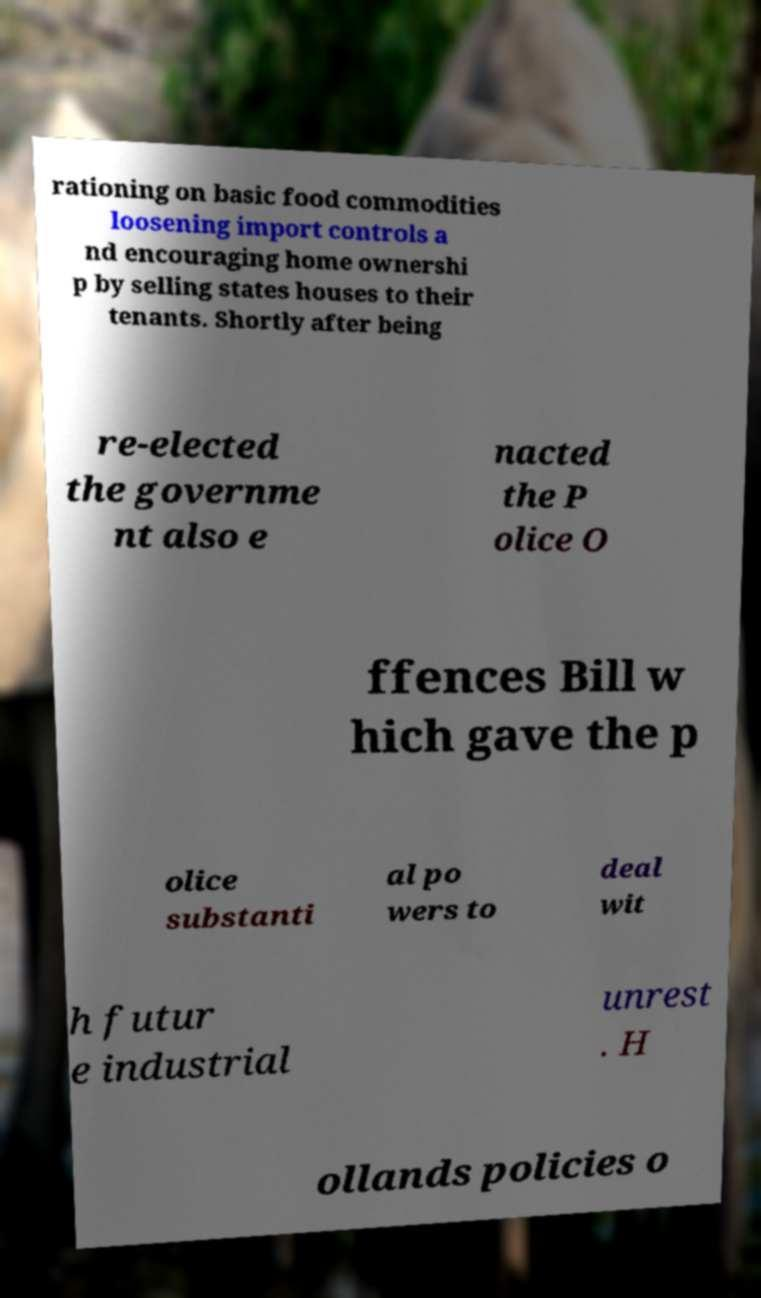For documentation purposes, I need the text within this image transcribed. Could you provide that? rationing on basic food commodities loosening import controls a nd encouraging home ownershi p by selling states houses to their tenants. Shortly after being re-elected the governme nt also e nacted the P olice O ffences Bill w hich gave the p olice substanti al po wers to deal wit h futur e industrial unrest . H ollands policies o 